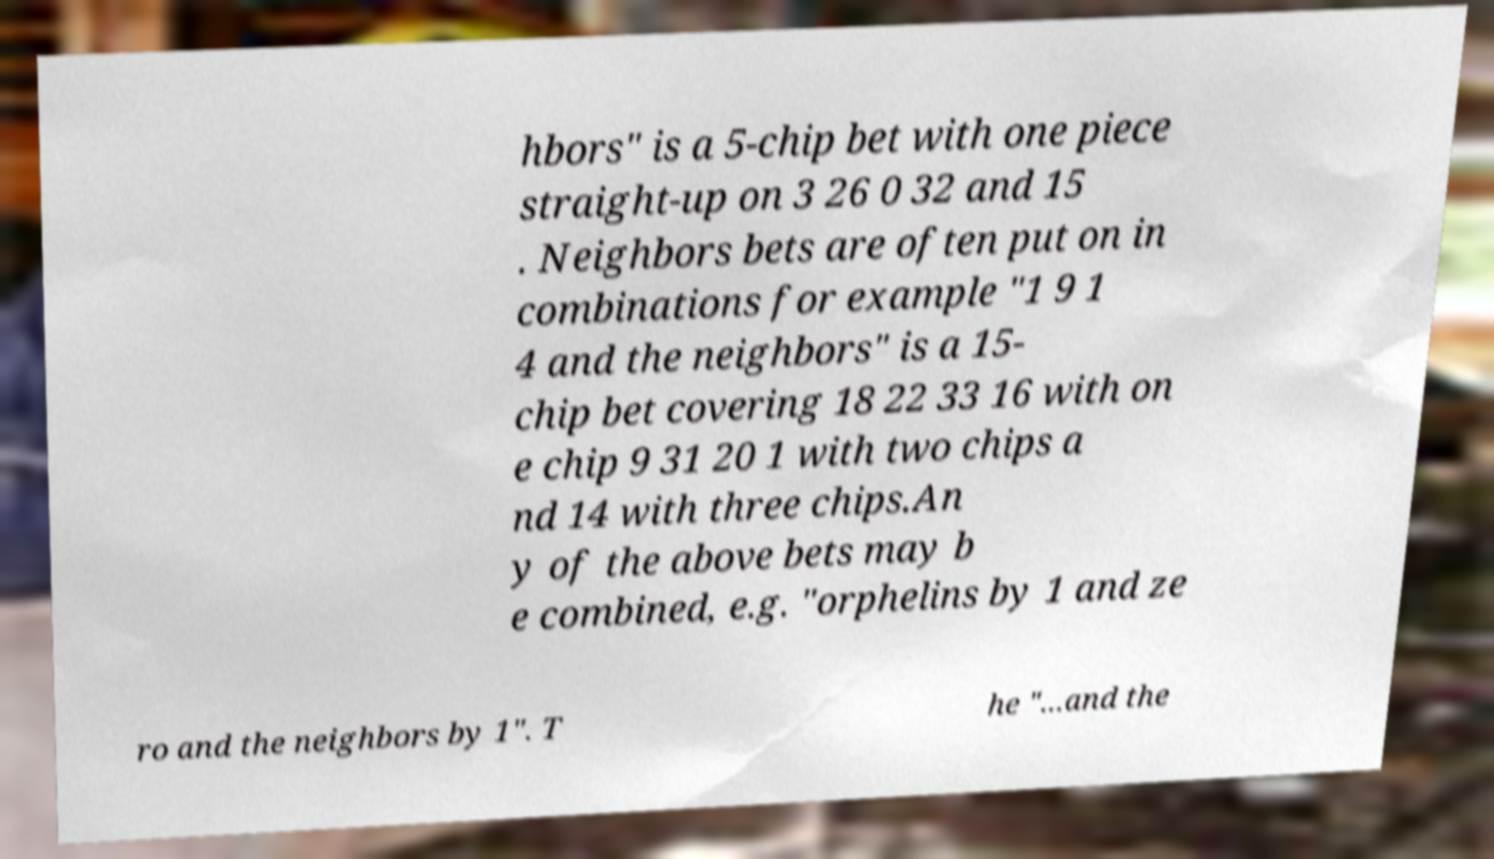Could you assist in decoding the text presented in this image and type it out clearly? hbors" is a 5-chip bet with one piece straight-up on 3 26 0 32 and 15 . Neighbors bets are often put on in combinations for example "1 9 1 4 and the neighbors" is a 15- chip bet covering 18 22 33 16 with on e chip 9 31 20 1 with two chips a nd 14 with three chips.An y of the above bets may b e combined, e.g. "orphelins by 1 and ze ro and the neighbors by 1". T he "...and the 